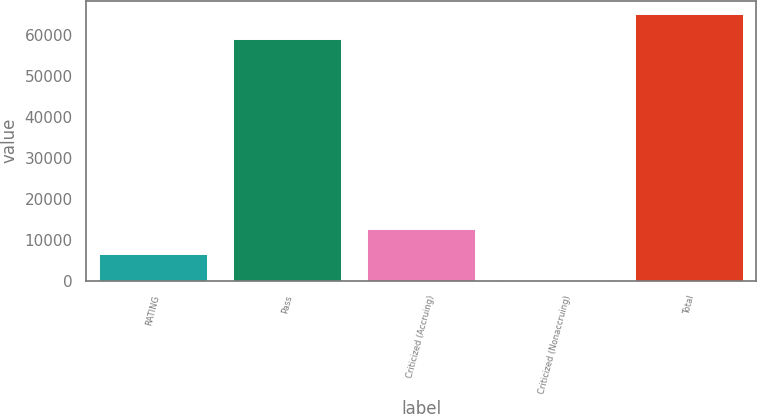Convert chart to OTSL. <chart><loc_0><loc_0><loc_500><loc_500><bar_chart><fcel>RATING<fcel>Pass<fcel>Criticized (Accruing)<fcel>Criticized (Nonaccruing)<fcel>Total<nl><fcel>6444.6<fcel>59072<fcel>12556.2<fcel>333<fcel>65183.6<nl></chart> 